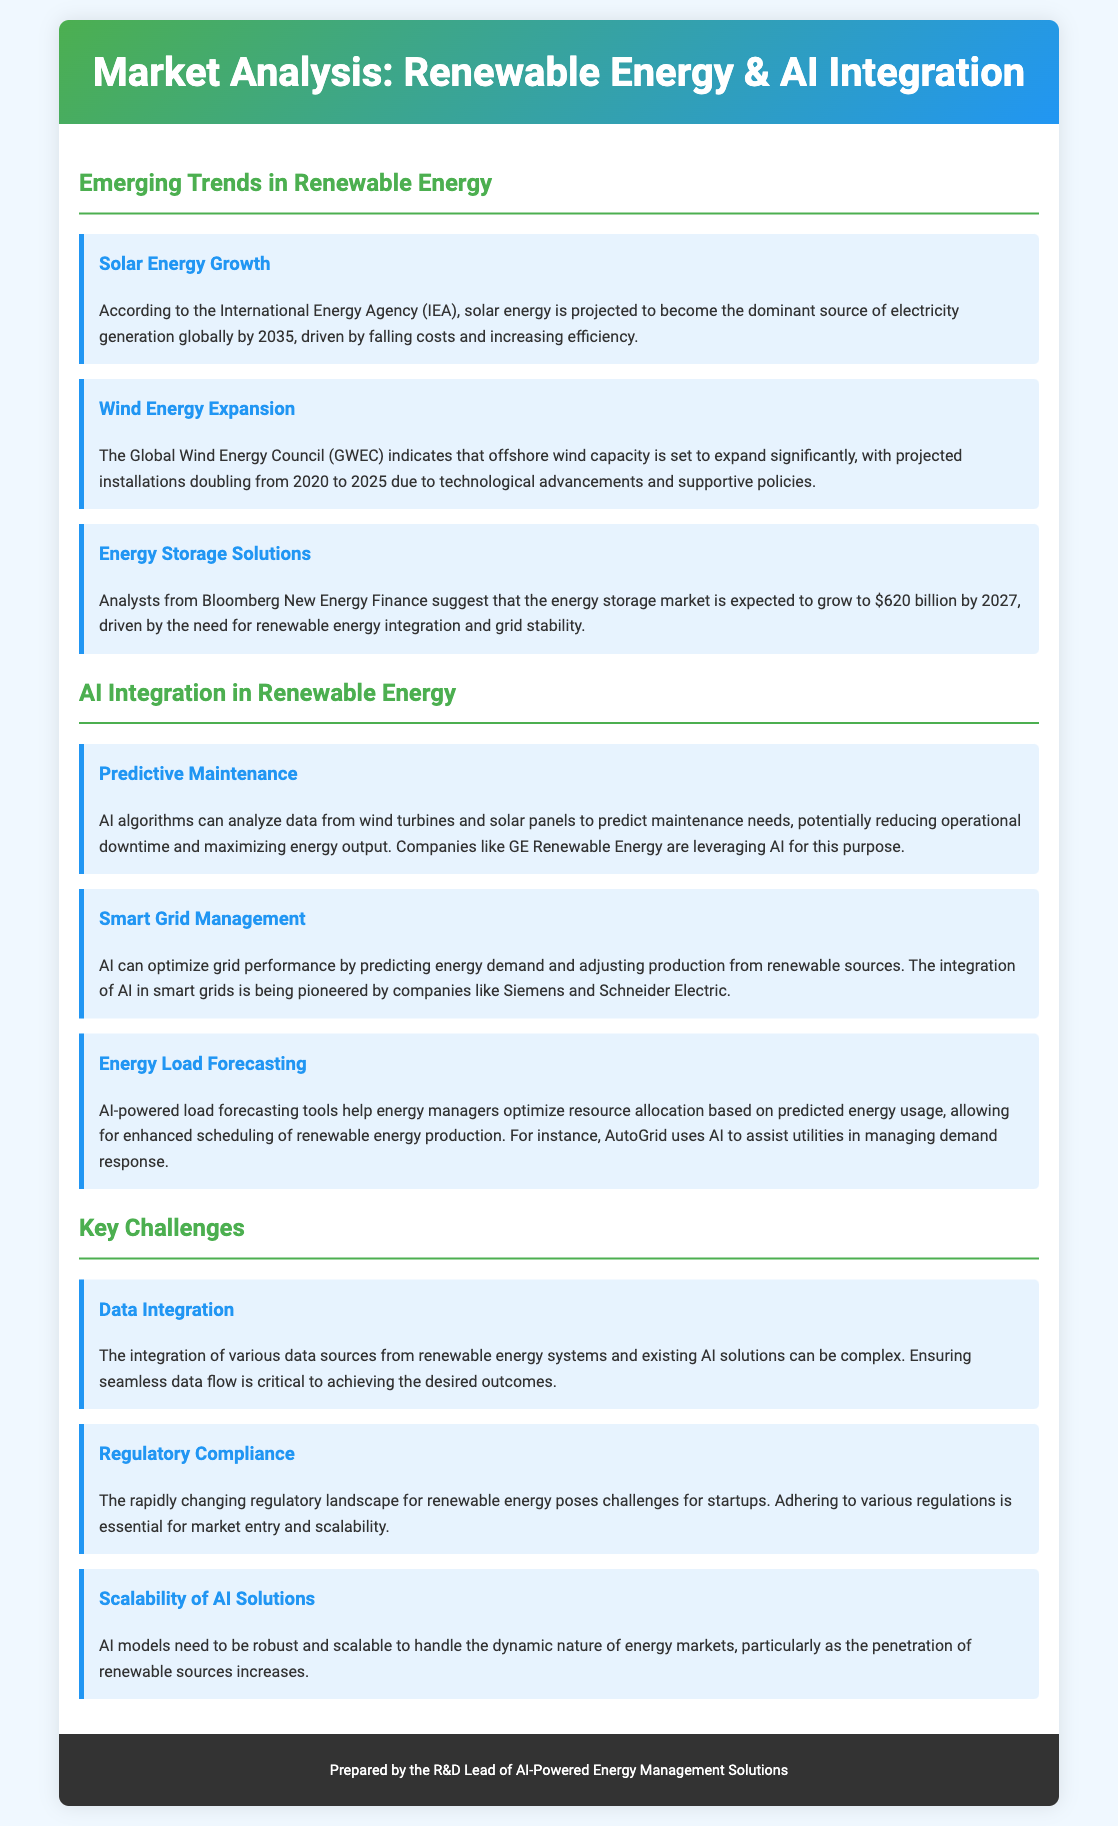What is the projected dominant source of electricity generation by 2035? The document states that solar energy is projected to become the dominant source of electricity generation globally by 2035.
Answer: Solar energy What is the expected growth of the energy storage market by 2027? Analysts from Bloomberg New Energy Finance suggest that the energy storage market is expected to grow to $620 billion by 2027.
Answer: $620 billion Which company uses AI algorithms for predictive maintenance in renewable energy? The document mentions that GE Renewable Energy leverages AI algorithms to predict maintenance needs.
Answer: GE Renewable Energy What is a key challenge related to integrating AI with renewable energy systems? The document identifies data integration as a complex issue crucial for achieving desired outcomes in AI and renewable energy systems.
Answer: Data Integration Which AI application optimizes grid performance according to energy demand? The document states that AI can optimize grid performance by predicting energy demand and adjusting renewable production.
Answer: Smart Grid Management What is the expected installation growth for offshore wind capacity by 2025? The Global Wind Energy Council indicates that offshore wind capacity is set to expand significantly, with projected installations doubling from 2020 to 2025.
Answer: Doubling What does AutoGrid use AI for in energy management? The document mentions that AutoGrid uses AI to assist utilities in managing demand response.
Answer: Demand response What is indicated as necessary for startups in the renewable energy market? The document emphasizes that adhering to various regulations is essential for market entry and scalability for startups.
Answer: Regulatory Compliance What is the estimated value of the energy storage market by 2027? According to Bloomberg New Energy Finance, the energy storage market is projected to reach $620 billion by 2027.
Answer: $620 billion 